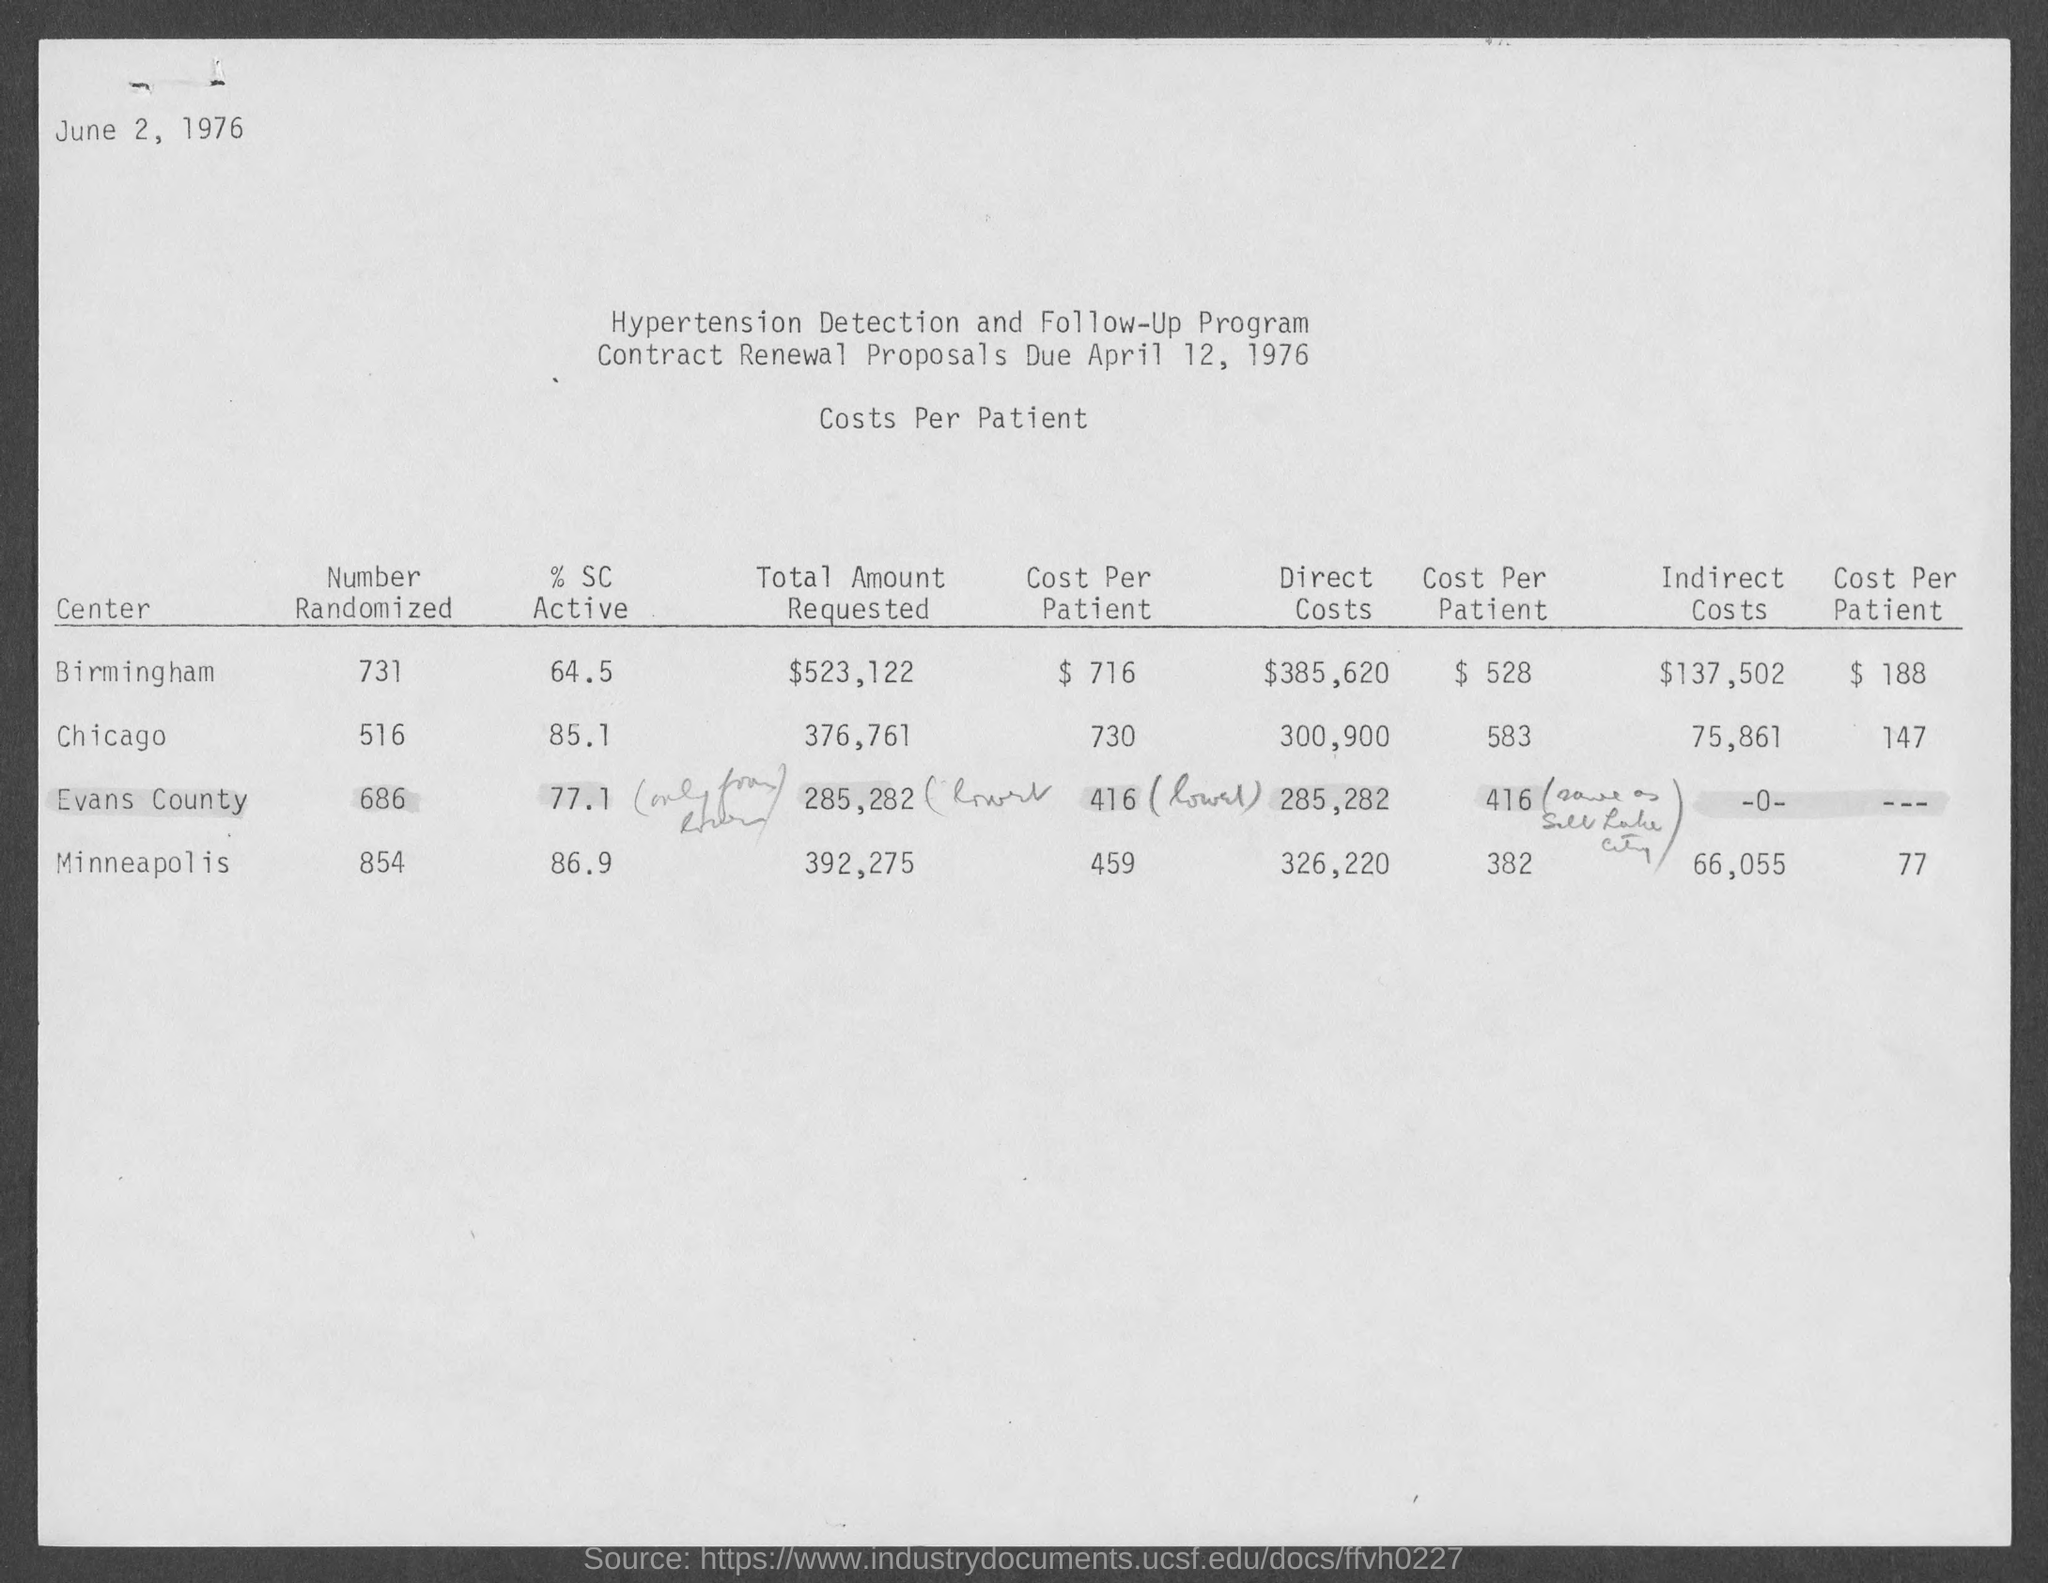Point out several critical features in this image. The center with indirect costs of $66,055 is located in Minneapolis. The corresponding % SC Active for Chicago is 85.1%. The contract renewal proposals are due on April 12, 1976. The total amount requested in the center of Birmingham is 523,122. The document is dated June 2, 1976. 